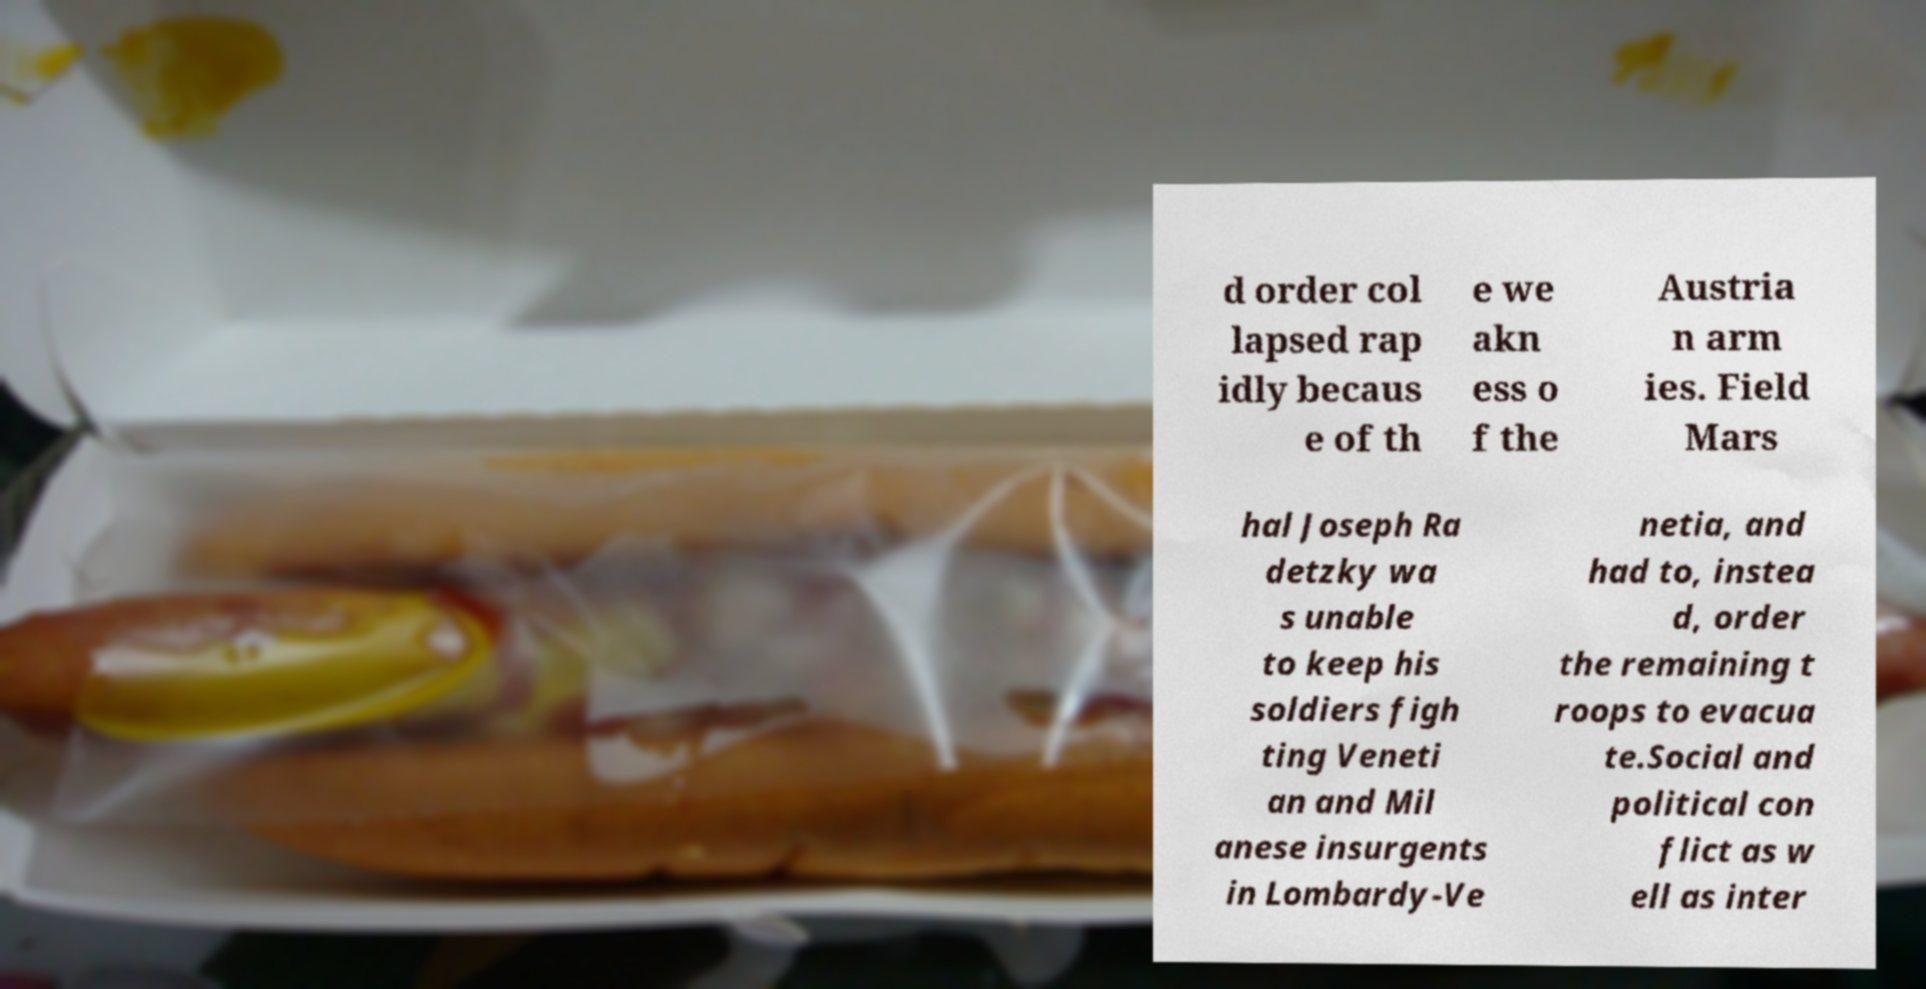For documentation purposes, I need the text within this image transcribed. Could you provide that? d order col lapsed rap idly becaus e of th e we akn ess o f the Austria n arm ies. Field Mars hal Joseph Ra detzky wa s unable to keep his soldiers figh ting Veneti an and Mil anese insurgents in Lombardy-Ve netia, and had to, instea d, order the remaining t roops to evacua te.Social and political con flict as w ell as inter 